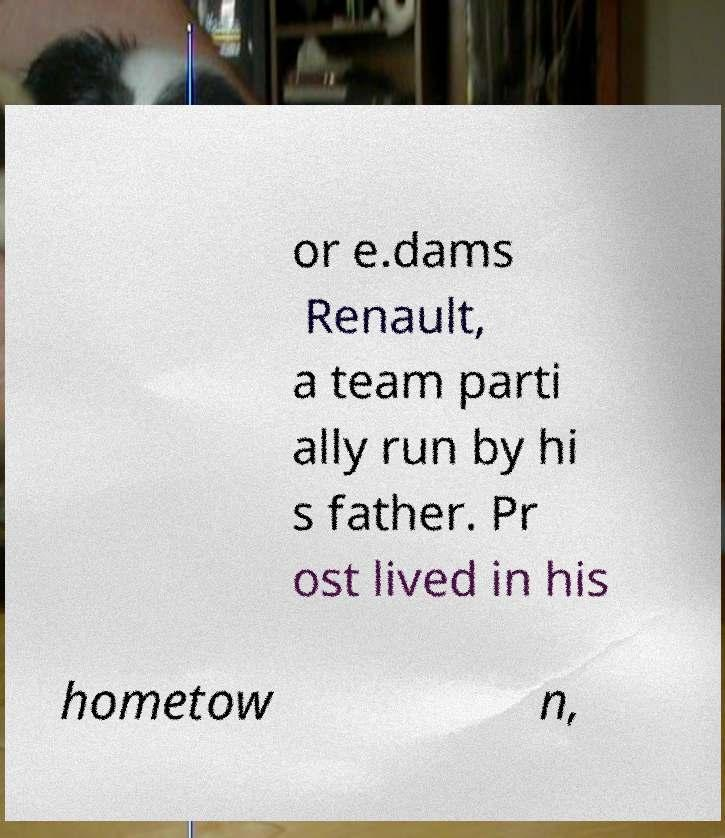Could you assist in decoding the text presented in this image and type it out clearly? or e.dams Renault, a team parti ally run by hi s father. Pr ost lived in his hometow n, 